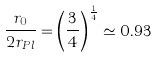Convert formula to latex. <formula><loc_0><loc_0><loc_500><loc_500>\frac { r _ { 0 } } { 2 r _ { P l } } = \left ( \frac { 3 } { 4 } \right ) ^ { \frac { 1 } { 4 } } \simeq 0 . 9 3</formula> 